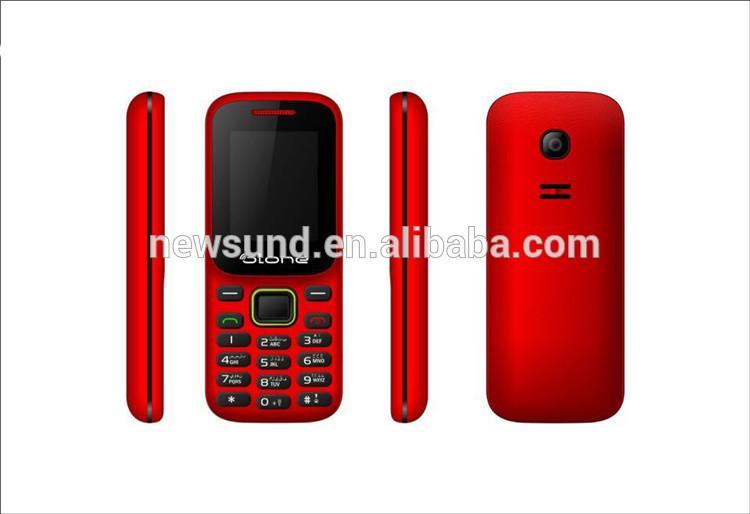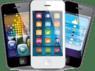The first image is the image on the left, the second image is the image on the right. Examine the images to the left and right. Is the description "In at least one image there are vertical phones." accurate? Answer yes or no. Yes. 